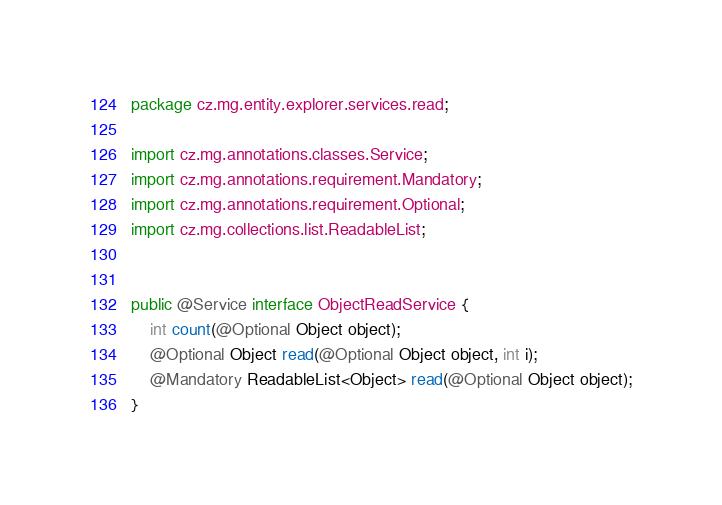Convert code to text. <code><loc_0><loc_0><loc_500><loc_500><_Java_>package cz.mg.entity.explorer.services.read;

import cz.mg.annotations.classes.Service;
import cz.mg.annotations.requirement.Mandatory;
import cz.mg.annotations.requirement.Optional;
import cz.mg.collections.list.ReadableList;


public @Service interface ObjectReadService {
    int count(@Optional Object object);
    @Optional Object read(@Optional Object object, int i);
    @Mandatory ReadableList<Object> read(@Optional Object object);
}
</code> 